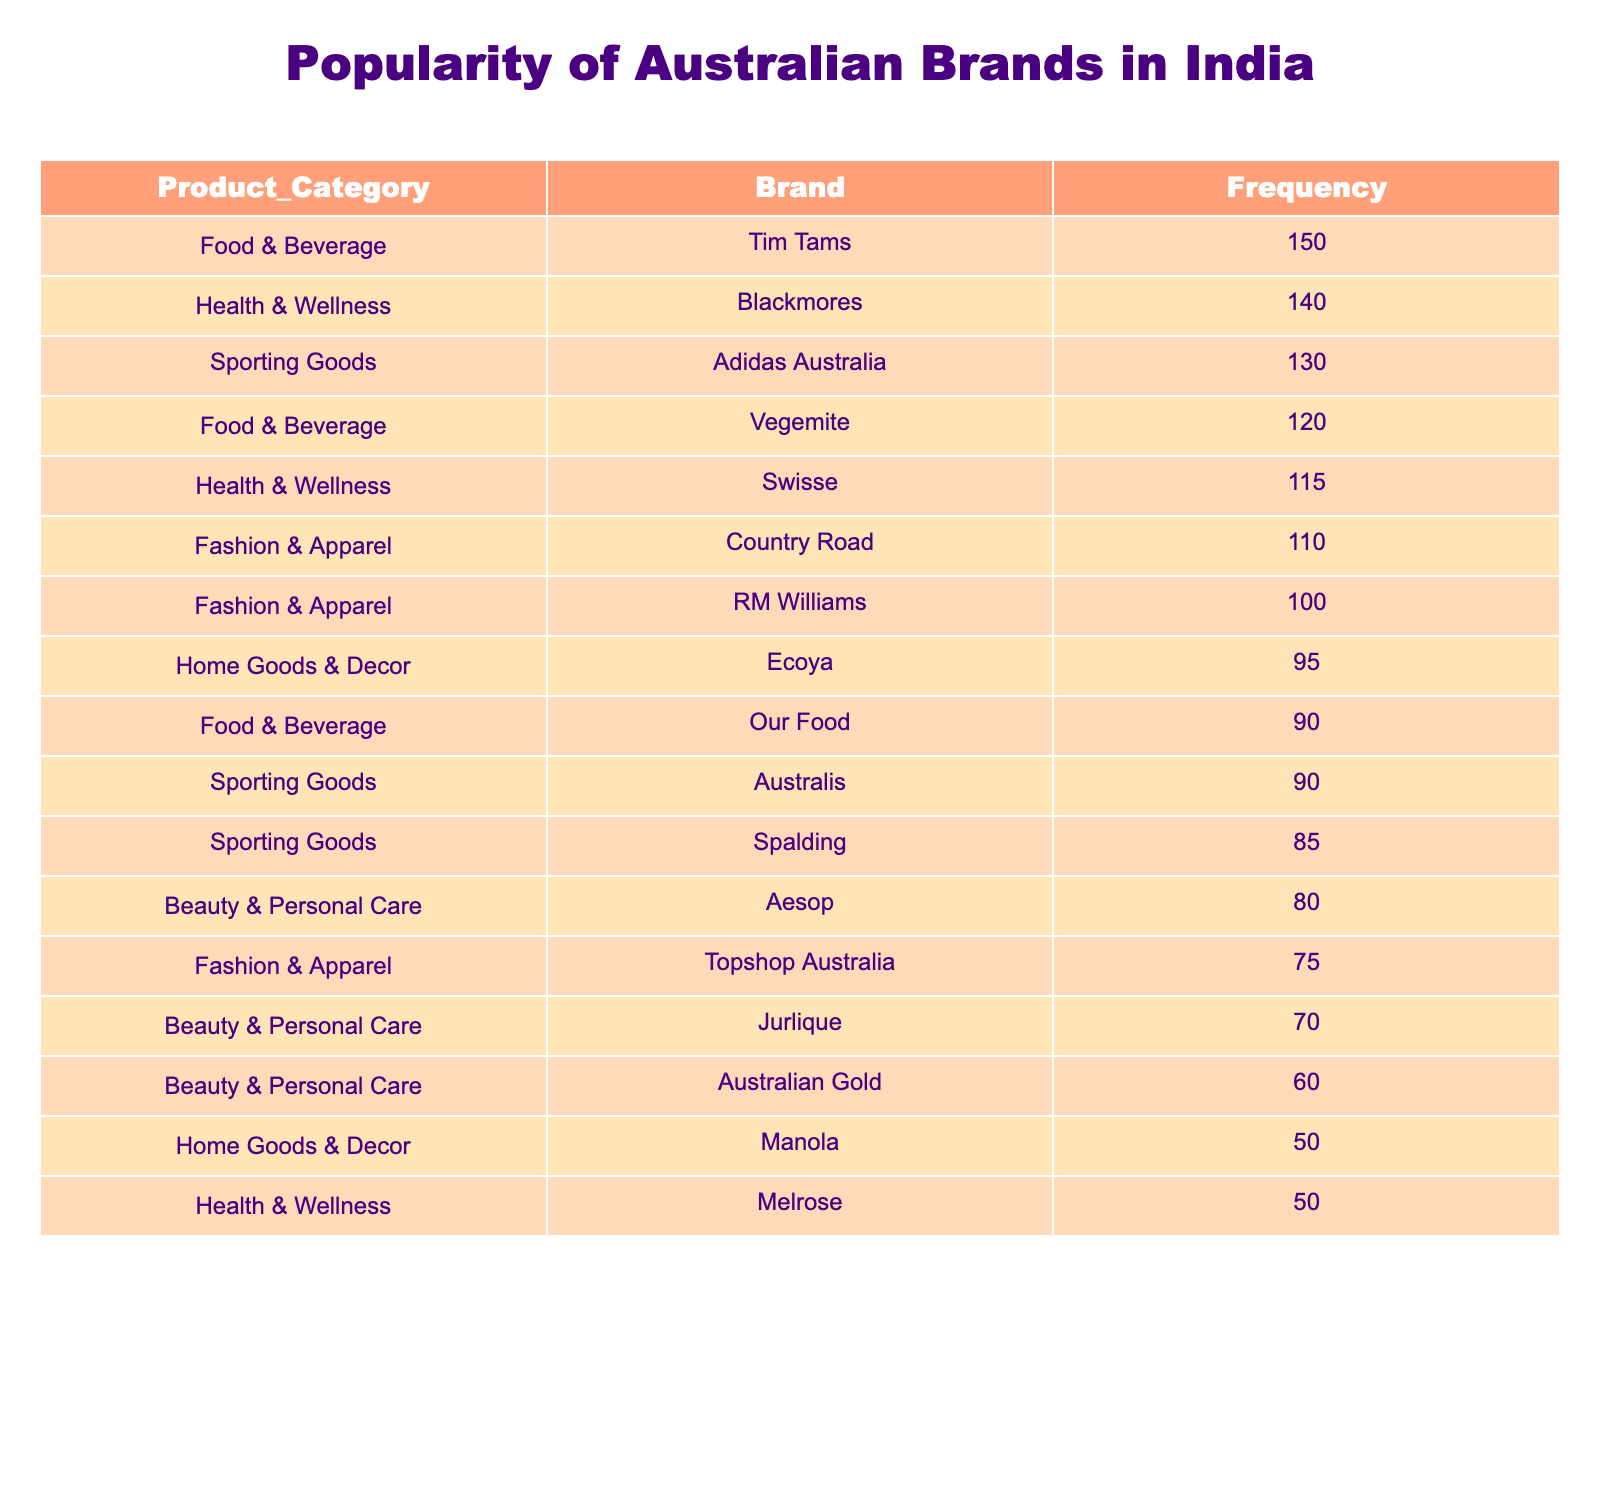What is the most popular Australian brand among Indian consumers? The highest frequency in the table is 150, which corresponds to the brand Tim Tams.
Answer: Tim Tams Which product category has the brand with the lowest popularity? The brand with the lowest frequency is Manola at 50, which is in the Home Goods & Decor category.
Answer: Home Goods & Decor How many brands in the Health & Wellness category have a frequency greater than 100? In the Health & Wellness category, Blackmores has 140 and Swisse has 115, totaling 2 brands with a frequency greater than 100.
Answer: 2 What is the average frequency of brands in the Sporting Goods category? The frequencies for the Sporting Goods category are 90 (Australis), 130 (Adidas Australia), and 85 (Spalding). Summing these gives 90 + 130 + 85 = 305. There are 3 brands, so the average is 305 / 3 = 101.67.
Answer: 101.67 Is the combined frequency of Food & Beverage brands greater than that of the Fashion & Apparel brands? The total frequency for Food & Beverage brands is 120 (Vegemite) + 150 (Tim Tams) + 90 (Our Food) = 360. For Fashion & Apparel, it's 100 (RM Williams) + 110 (Country Road) + 75 (Topshop Australia) = 285. Since 360 is greater than 285, the answer is yes.
Answer: Yes Which brand in the Beauty & Personal Care category has a frequency closest to 70? The brands are Aesop with a frequency of 80, Jurlique with 70, and Australian Gold with 60. Jurlique has a frequency exactly equal to 70.
Answer: Jurlique What is the difference in frequency between the most popular and least popular brand overall? The most popular brand is Tim Tams with a frequency of 150, and the least popular is Manola with a frequency of 50. The difference is 150 - 50 = 100.
Answer: 100 How many product categories contain more than two brands? The categories are Food & Beverage (3 brands), Beauty & Personal Care (3 brands), and Health & Wellness (3 brands). Since each has more than 2 brands, there are 3 categories that fit this criterion.
Answer: 3 